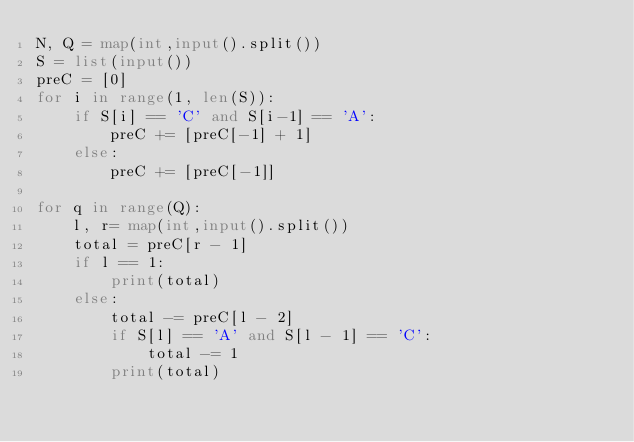Convert code to text. <code><loc_0><loc_0><loc_500><loc_500><_Python_>N, Q = map(int,input().split())
S = list(input())
preC = [0]
for i in range(1, len(S)):
    if S[i] == 'C' and S[i-1] == 'A':
        preC += [preC[-1] + 1]
    else:
        preC += [preC[-1]]

for q in range(Q):
    l, r= map(int,input().split())
    total = preC[r - 1]
    if l == 1:
        print(total)
    else:
        total -= preC[l - 2]
        if S[l] == 'A' and S[l - 1] == 'C':
            total -= 1
        print(total)        
        
</code> 